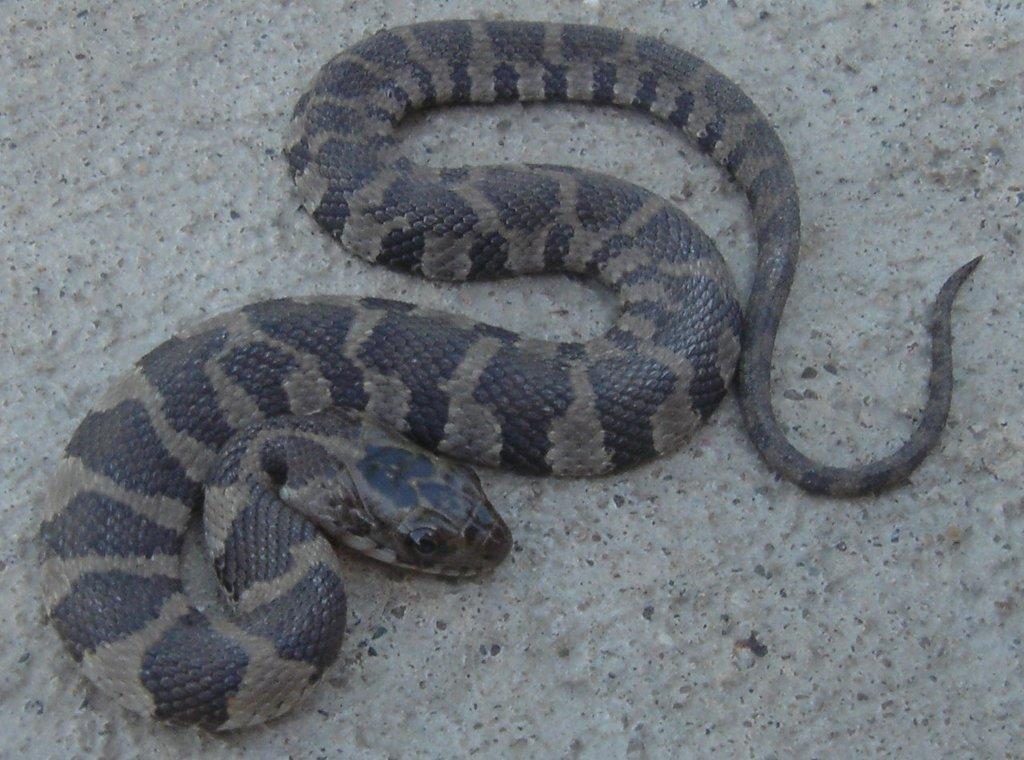Describe this image in one or two sentences. In this image we can see a snake on the ground. 